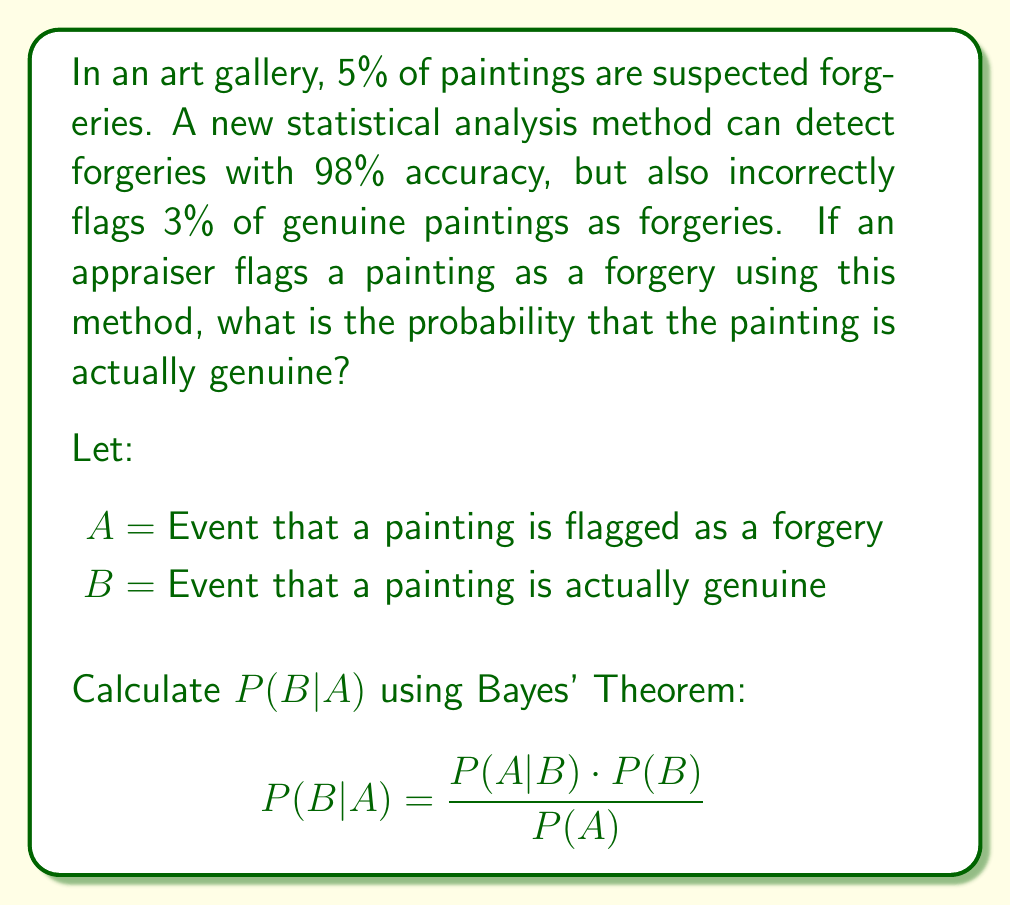Teach me how to tackle this problem. 1. Define the given probabilities:
   P(B) = 0.95 (95% of paintings are genuine)
   P(A|B) = 0.03 (3% of genuine paintings are incorrectly flagged)
   P(A|not B) = 0.98 (98% of forgeries are correctly flagged)

2. Calculate P(A) using the law of total probability:
   $$P(A) = P(A|B) \cdot P(B) + P(A|not B) \cdot P(not B)$$
   $$P(A) = 0.03 \cdot 0.95 + 0.98 \cdot 0.05$$
   $$P(A) = 0.0285 + 0.049 = 0.0775$$

3. Apply Bayes' Theorem:
   $$P(B|A) = \frac{P(A|B) \cdot P(B)}{P(A)}$$
   $$P(B|A) = \frac{0.03 \cdot 0.95}{0.0775}$$
   $$P(B|A) = \frac{0.0285}{0.0775} \approx 0.3677$$

4. Convert to percentage:
   0.3677 * 100% ≈ 36.77%
Answer: 36.77% 